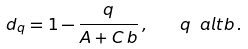<formula> <loc_0><loc_0><loc_500><loc_500>d _ { q } = 1 - \frac { q } { A + C \, b } \, , \quad q \ a l t b \, .</formula> 